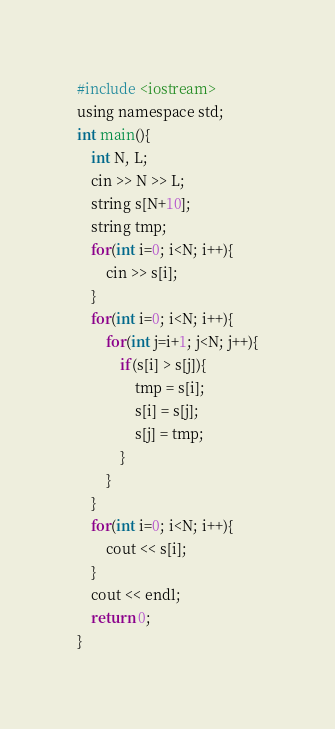<code> <loc_0><loc_0><loc_500><loc_500><_C_>#include <iostream>
using namespace std;
int main(){
    int N, L;
    cin >> N >> L;
    string s[N+10];
    string tmp;
    for(int i=0; i<N; i++){
        cin >> s[i];
    }
    for(int i=0; i<N; i++){
        for(int j=i+1; j<N; j++){
            if(s[i] > s[j]){
                tmp = s[i];
                s[i] = s[j];
                s[j] = tmp;
            }
        }
    }
    for(int i=0; i<N; i++){
        cout << s[i];
    }
    cout << endl;
    return 0;
}</code> 